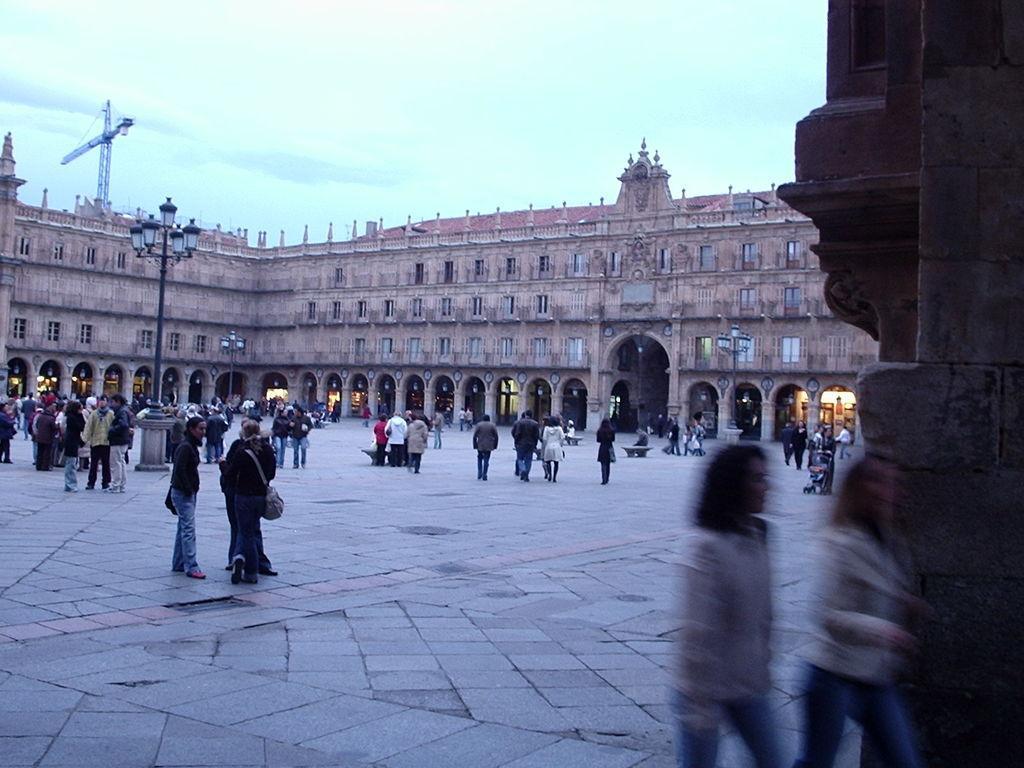Please provide a concise description of this image. This is an outside view. In this image I can see many people are walking on the ground. On the right side there is a wall with some carvings. In the background there is a building. On the left side there is a light pole and a crane. At the top of the image I can see the sky. 